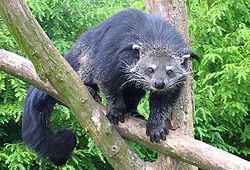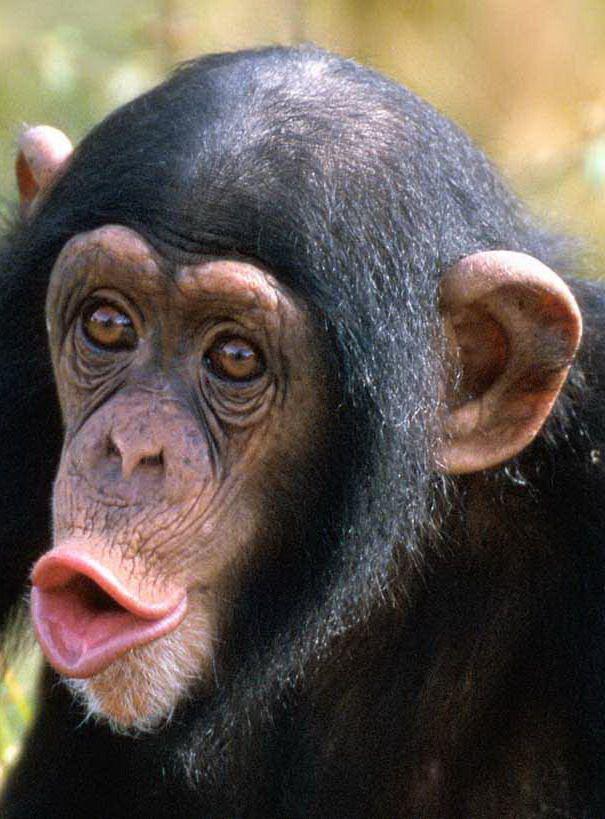The first image is the image on the left, the second image is the image on the right. For the images displayed, is the sentence "In one image a chimp is making an O shape with their mouth" factually correct? Answer yes or no. Yes. 